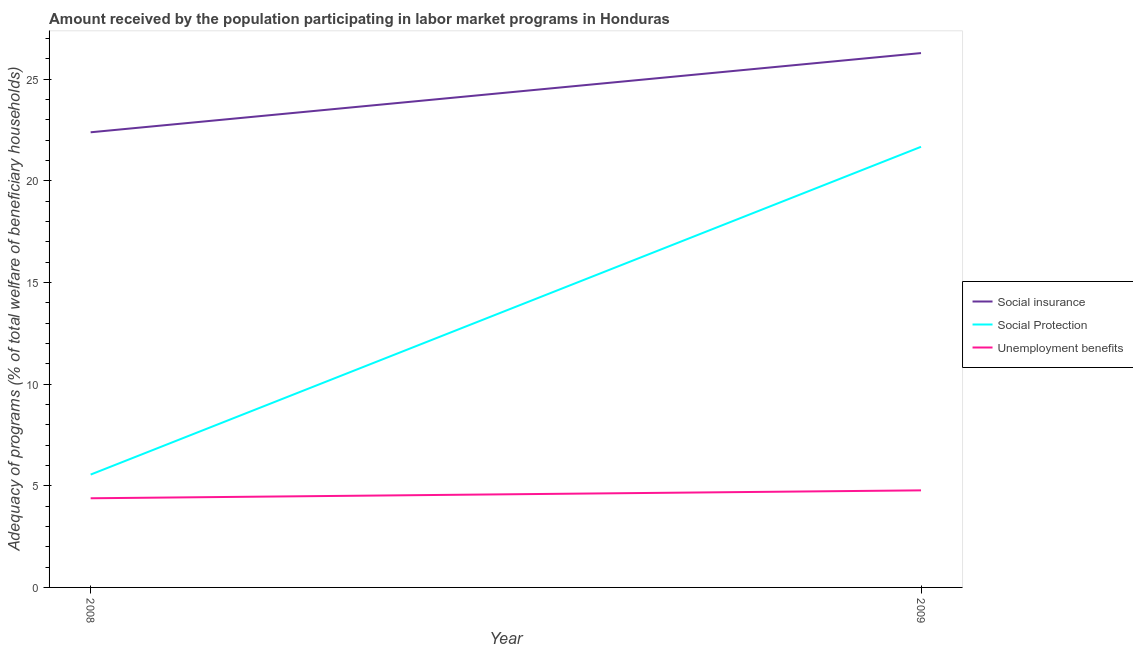How many different coloured lines are there?
Provide a succinct answer. 3. Does the line corresponding to amount received by the population participating in unemployment benefits programs intersect with the line corresponding to amount received by the population participating in social protection programs?
Ensure brevity in your answer.  No. Is the number of lines equal to the number of legend labels?
Your answer should be very brief. Yes. What is the amount received by the population participating in social insurance programs in 2009?
Provide a succinct answer. 26.28. Across all years, what is the maximum amount received by the population participating in unemployment benefits programs?
Give a very brief answer. 4.77. Across all years, what is the minimum amount received by the population participating in social insurance programs?
Your answer should be very brief. 22.39. In which year was the amount received by the population participating in social protection programs maximum?
Make the answer very short. 2009. In which year was the amount received by the population participating in social insurance programs minimum?
Ensure brevity in your answer.  2008. What is the total amount received by the population participating in unemployment benefits programs in the graph?
Offer a terse response. 9.16. What is the difference between the amount received by the population participating in social protection programs in 2008 and that in 2009?
Make the answer very short. -16.12. What is the difference between the amount received by the population participating in social protection programs in 2008 and the amount received by the population participating in unemployment benefits programs in 2009?
Keep it short and to the point. 0.78. What is the average amount received by the population participating in unemployment benefits programs per year?
Make the answer very short. 4.58. In the year 2009, what is the difference between the amount received by the population participating in social insurance programs and amount received by the population participating in unemployment benefits programs?
Provide a succinct answer. 21.51. What is the ratio of the amount received by the population participating in unemployment benefits programs in 2008 to that in 2009?
Ensure brevity in your answer.  0.92. Is it the case that in every year, the sum of the amount received by the population participating in social insurance programs and amount received by the population participating in social protection programs is greater than the amount received by the population participating in unemployment benefits programs?
Your answer should be compact. Yes. Does the amount received by the population participating in unemployment benefits programs monotonically increase over the years?
Make the answer very short. Yes. How many years are there in the graph?
Your answer should be compact. 2. What is the difference between two consecutive major ticks on the Y-axis?
Offer a terse response. 5. Are the values on the major ticks of Y-axis written in scientific E-notation?
Provide a succinct answer. No. Does the graph contain grids?
Ensure brevity in your answer.  No. Where does the legend appear in the graph?
Keep it short and to the point. Center right. How are the legend labels stacked?
Provide a short and direct response. Vertical. What is the title of the graph?
Give a very brief answer. Amount received by the population participating in labor market programs in Honduras. Does "Male employers" appear as one of the legend labels in the graph?
Keep it short and to the point. No. What is the label or title of the Y-axis?
Provide a short and direct response. Adequacy of programs (% of total welfare of beneficiary households). What is the Adequacy of programs (% of total welfare of beneficiary households) of Social insurance in 2008?
Keep it short and to the point. 22.39. What is the Adequacy of programs (% of total welfare of beneficiary households) in Social Protection in 2008?
Ensure brevity in your answer.  5.55. What is the Adequacy of programs (% of total welfare of beneficiary households) in Unemployment benefits in 2008?
Provide a succinct answer. 4.39. What is the Adequacy of programs (% of total welfare of beneficiary households) in Social insurance in 2009?
Keep it short and to the point. 26.28. What is the Adequacy of programs (% of total welfare of beneficiary households) of Social Protection in 2009?
Your answer should be compact. 21.67. What is the Adequacy of programs (% of total welfare of beneficiary households) of Unemployment benefits in 2009?
Offer a terse response. 4.77. Across all years, what is the maximum Adequacy of programs (% of total welfare of beneficiary households) of Social insurance?
Keep it short and to the point. 26.28. Across all years, what is the maximum Adequacy of programs (% of total welfare of beneficiary households) in Social Protection?
Your answer should be very brief. 21.67. Across all years, what is the maximum Adequacy of programs (% of total welfare of beneficiary households) of Unemployment benefits?
Make the answer very short. 4.77. Across all years, what is the minimum Adequacy of programs (% of total welfare of beneficiary households) in Social insurance?
Your response must be concise. 22.39. Across all years, what is the minimum Adequacy of programs (% of total welfare of beneficiary households) of Social Protection?
Offer a very short reply. 5.55. Across all years, what is the minimum Adequacy of programs (% of total welfare of beneficiary households) of Unemployment benefits?
Offer a very short reply. 4.39. What is the total Adequacy of programs (% of total welfare of beneficiary households) of Social insurance in the graph?
Your response must be concise. 48.67. What is the total Adequacy of programs (% of total welfare of beneficiary households) of Social Protection in the graph?
Make the answer very short. 27.22. What is the total Adequacy of programs (% of total welfare of beneficiary households) of Unemployment benefits in the graph?
Your response must be concise. 9.16. What is the difference between the Adequacy of programs (% of total welfare of beneficiary households) in Social insurance in 2008 and that in 2009?
Offer a terse response. -3.9. What is the difference between the Adequacy of programs (% of total welfare of beneficiary households) in Social Protection in 2008 and that in 2009?
Keep it short and to the point. -16.12. What is the difference between the Adequacy of programs (% of total welfare of beneficiary households) of Unemployment benefits in 2008 and that in 2009?
Give a very brief answer. -0.39. What is the difference between the Adequacy of programs (% of total welfare of beneficiary households) of Social insurance in 2008 and the Adequacy of programs (% of total welfare of beneficiary households) of Social Protection in 2009?
Ensure brevity in your answer.  0.71. What is the difference between the Adequacy of programs (% of total welfare of beneficiary households) in Social insurance in 2008 and the Adequacy of programs (% of total welfare of beneficiary households) in Unemployment benefits in 2009?
Make the answer very short. 17.61. What is the difference between the Adequacy of programs (% of total welfare of beneficiary households) in Social Protection in 2008 and the Adequacy of programs (% of total welfare of beneficiary households) in Unemployment benefits in 2009?
Your answer should be compact. 0.78. What is the average Adequacy of programs (% of total welfare of beneficiary households) in Social insurance per year?
Provide a succinct answer. 24.34. What is the average Adequacy of programs (% of total welfare of beneficiary households) in Social Protection per year?
Make the answer very short. 13.61. What is the average Adequacy of programs (% of total welfare of beneficiary households) of Unemployment benefits per year?
Keep it short and to the point. 4.58. In the year 2008, what is the difference between the Adequacy of programs (% of total welfare of beneficiary households) in Social insurance and Adequacy of programs (% of total welfare of beneficiary households) in Social Protection?
Provide a short and direct response. 16.84. In the year 2008, what is the difference between the Adequacy of programs (% of total welfare of beneficiary households) in Social insurance and Adequacy of programs (% of total welfare of beneficiary households) in Unemployment benefits?
Offer a very short reply. 18. In the year 2008, what is the difference between the Adequacy of programs (% of total welfare of beneficiary households) in Social Protection and Adequacy of programs (% of total welfare of beneficiary households) in Unemployment benefits?
Your answer should be compact. 1.17. In the year 2009, what is the difference between the Adequacy of programs (% of total welfare of beneficiary households) of Social insurance and Adequacy of programs (% of total welfare of beneficiary households) of Social Protection?
Offer a very short reply. 4.61. In the year 2009, what is the difference between the Adequacy of programs (% of total welfare of beneficiary households) in Social insurance and Adequacy of programs (% of total welfare of beneficiary households) in Unemployment benefits?
Ensure brevity in your answer.  21.51. In the year 2009, what is the difference between the Adequacy of programs (% of total welfare of beneficiary households) in Social Protection and Adequacy of programs (% of total welfare of beneficiary households) in Unemployment benefits?
Make the answer very short. 16.9. What is the ratio of the Adequacy of programs (% of total welfare of beneficiary households) in Social insurance in 2008 to that in 2009?
Ensure brevity in your answer.  0.85. What is the ratio of the Adequacy of programs (% of total welfare of beneficiary households) in Social Protection in 2008 to that in 2009?
Offer a very short reply. 0.26. What is the ratio of the Adequacy of programs (% of total welfare of beneficiary households) of Unemployment benefits in 2008 to that in 2009?
Your answer should be very brief. 0.92. What is the difference between the highest and the second highest Adequacy of programs (% of total welfare of beneficiary households) of Social insurance?
Make the answer very short. 3.9. What is the difference between the highest and the second highest Adequacy of programs (% of total welfare of beneficiary households) of Social Protection?
Offer a terse response. 16.12. What is the difference between the highest and the second highest Adequacy of programs (% of total welfare of beneficiary households) of Unemployment benefits?
Give a very brief answer. 0.39. What is the difference between the highest and the lowest Adequacy of programs (% of total welfare of beneficiary households) in Social insurance?
Your answer should be compact. 3.9. What is the difference between the highest and the lowest Adequacy of programs (% of total welfare of beneficiary households) in Social Protection?
Give a very brief answer. 16.12. What is the difference between the highest and the lowest Adequacy of programs (% of total welfare of beneficiary households) in Unemployment benefits?
Offer a very short reply. 0.39. 